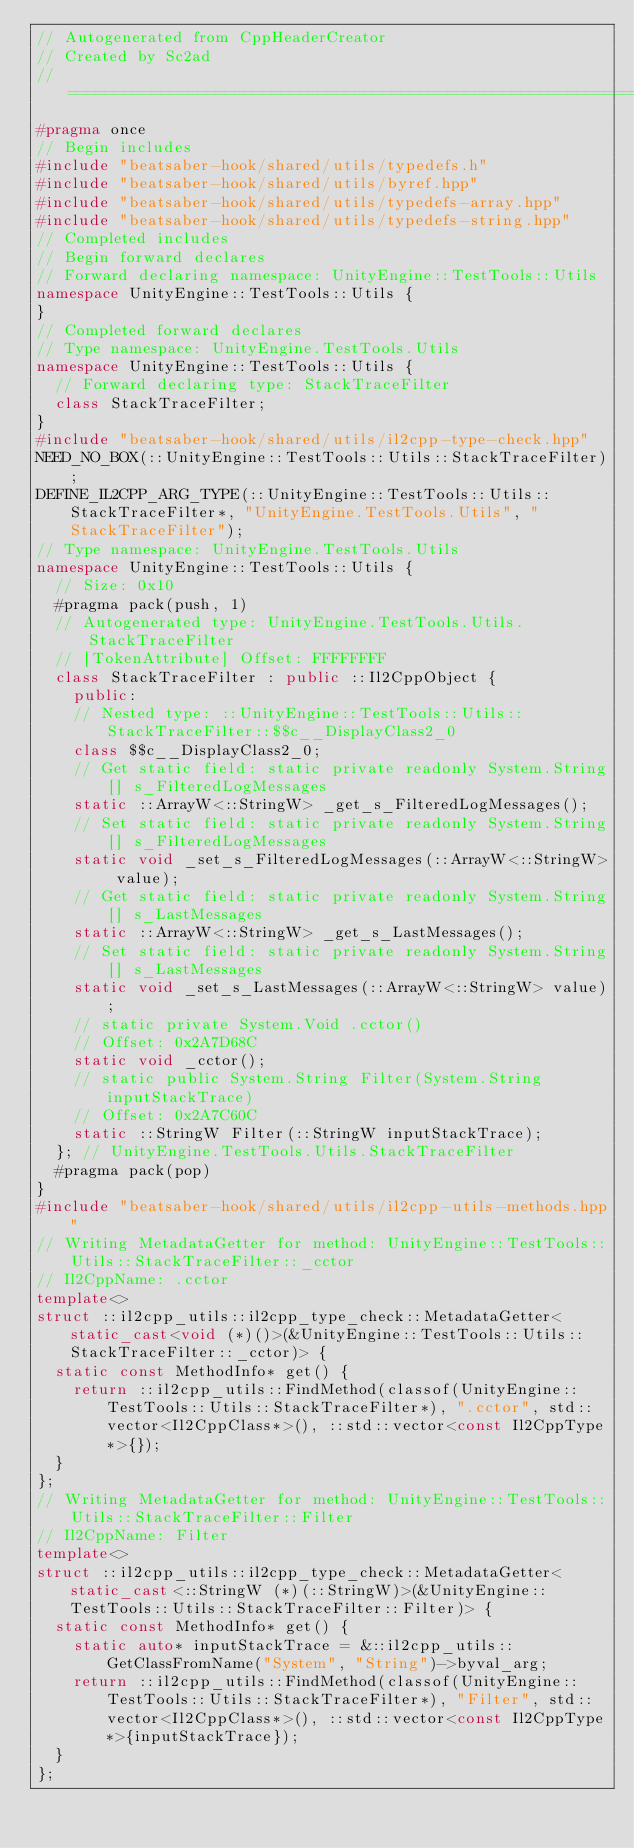Convert code to text. <code><loc_0><loc_0><loc_500><loc_500><_C++_>// Autogenerated from CppHeaderCreator
// Created by Sc2ad
// =========================================================================
#pragma once
// Begin includes
#include "beatsaber-hook/shared/utils/typedefs.h"
#include "beatsaber-hook/shared/utils/byref.hpp"
#include "beatsaber-hook/shared/utils/typedefs-array.hpp"
#include "beatsaber-hook/shared/utils/typedefs-string.hpp"
// Completed includes
// Begin forward declares
// Forward declaring namespace: UnityEngine::TestTools::Utils
namespace UnityEngine::TestTools::Utils {
}
// Completed forward declares
// Type namespace: UnityEngine.TestTools.Utils
namespace UnityEngine::TestTools::Utils {
  // Forward declaring type: StackTraceFilter
  class StackTraceFilter;
}
#include "beatsaber-hook/shared/utils/il2cpp-type-check.hpp"
NEED_NO_BOX(::UnityEngine::TestTools::Utils::StackTraceFilter);
DEFINE_IL2CPP_ARG_TYPE(::UnityEngine::TestTools::Utils::StackTraceFilter*, "UnityEngine.TestTools.Utils", "StackTraceFilter");
// Type namespace: UnityEngine.TestTools.Utils
namespace UnityEngine::TestTools::Utils {
  // Size: 0x10
  #pragma pack(push, 1)
  // Autogenerated type: UnityEngine.TestTools.Utils.StackTraceFilter
  // [TokenAttribute] Offset: FFFFFFFF
  class StackTraceFilter : public ::Il2CppObject {
    public:
    // Nested type: ::UnityEngine::TestTools::Utils::StackTraceFilter::$$c__DisplayClass2_0
    class $$c__DisplayClass2_0;
    // Get static field: static private readonly System.String[] s_FilteredLogMessages
    static ::ArrayW<::StringW> _get_s_FilteredLogMessages();
    // Set static field: static private readonly System.String[] s_FilteredLogMessages
    static void _set_s_FilteredLogMessages(::ArrayW<::StringW> value);
    // Get static field: static private readonly System.String[] s_LastMessages
    static ::ArrayW<::StringW> _get_s_LastMessages();
    // Set static field: static private readonly System.String[] s_LastMessages
    static void _set_s_LastMessages(::ArrayW<::StringW> value);
    // static private System.Void .cctor()
    // Offset: 0x2A7D68C
    static void _cctor();
    // static public System.String Filter(System.String inputStackTrace)
    // Offset: 0x2A7C60C
    static ::StringW Filter(::StringW inputStackTrace);
  }; // UnityEngine.TestTools.Utils.StackTraceFilter
  #pragma pack(pop)
}
#include "beatsaber-hook/shared/utils/il2cpp-utils-methods.hpp"
// Writing MetadataGetter for method: UnityEngine::TestTools::Utils::StackTraceFilter::_cctor
// Il2CppName: .cctor
template<>
struct ::il2cpp_utils::il2cpp_type_check::MetadataGetter<static_cast<void (*)()>(&UnityEngine::TestTools::Utils::StackTraceFilter::_cctor)> {
  static const MethodInfo* get() {
    return ::il2cpp_utils::FindMethod(classof(UnityEngine::TestTools::Utils::StackTraceFilter*), ".cctor", std::vector<Il2CppClass*>(), ::std::vector<const Il2CppType*>{});
  }
};
// Writing MetadataGetter for method: UnityEngine::TestTools::Utils::StackTraceFilter::Filter
// Il2CppName: Filter
template<>
struct ::il2cpp_utils::il2cpp_type_check::MetadataGetter<static_cast<::StringW (*)(::StringW)>(&UnityEngine::TestTools::Utils::StackTraceFilter::Filter)> {
  static const MethodInfo* get() {
    static auto* inputStackTrace = &::il2cpp_utils::GetClassFromName("System", "String")->byval_arg;
    return ::il2cpp_utils::FindMethod(classof(UnityEngine::TestTools::Utils::StackTraceFilter*), "Filter", std::vector<Il2CppClass*>(), ::std::vector<const Il2CppType*>{inputStackTrace});
  }
};
</code> 